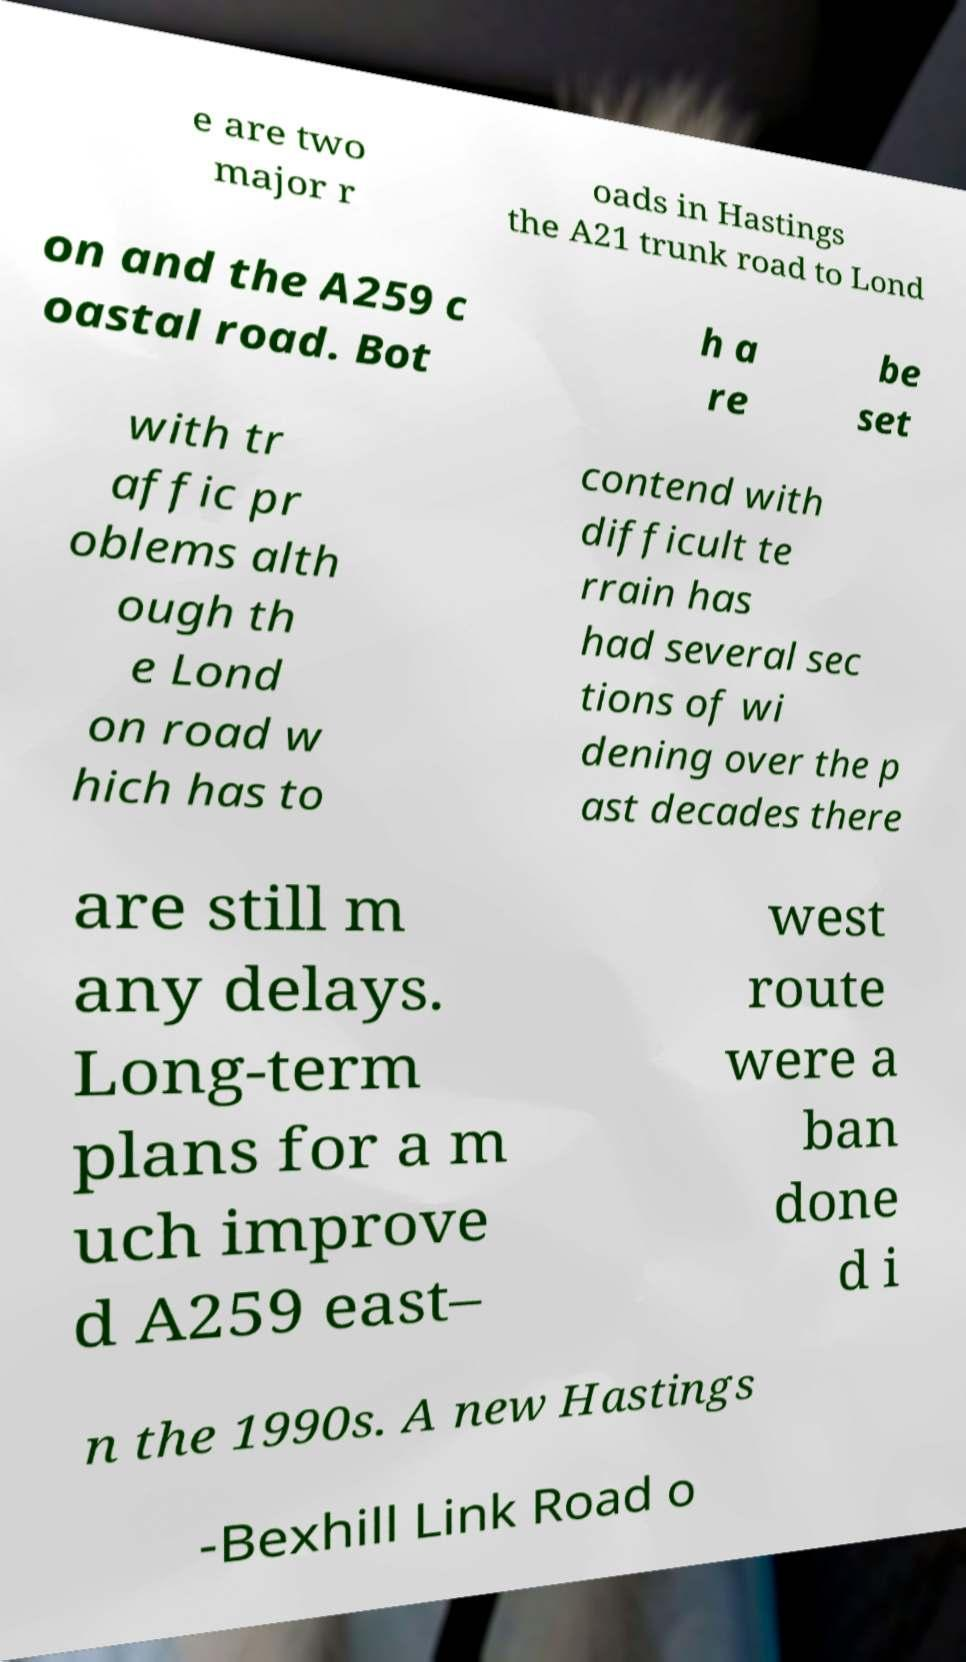Please read and relay the text visible in this image. What does it say? e are two major r oads in Hastings the A21 trunk road to Lond on and the A259 c oastal road. Bot h a re be set with tr affic pr oblems alth ough th e Lond on road w hich has to contend with difficult te rrain has had several sec tions of wi dening over the p ast decades there are still m any delays. Long-term plans for a m uch improve d A259 east– west route were a ban done d i n the 1990s. A new Hastings -Bexhill Link Road o 